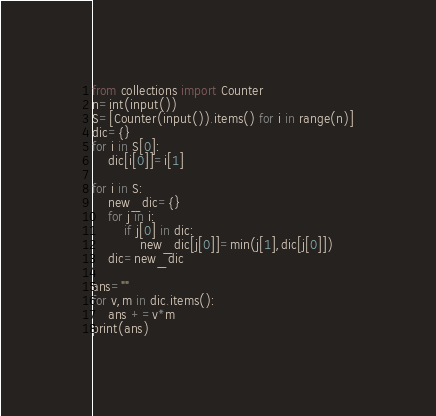<code> <loc_0><loc_0><loc_500><loc_500><_Python_>from collections import Counter
n=int(input())
S=[Counter(input()).items() for i in range(n)]
dic={}
for i in S[0]:
    dic[i[0]]=i[1]

for i in S:
    new_dic={}
    for j in i:
        if j[0] in dic:
            new_dic[j[0]]=min(j[1],dic[j[0]])
    dic=new_dic

ans=""
for v,m in dic.items():
    ans +=v*m
print(ans)</code> 